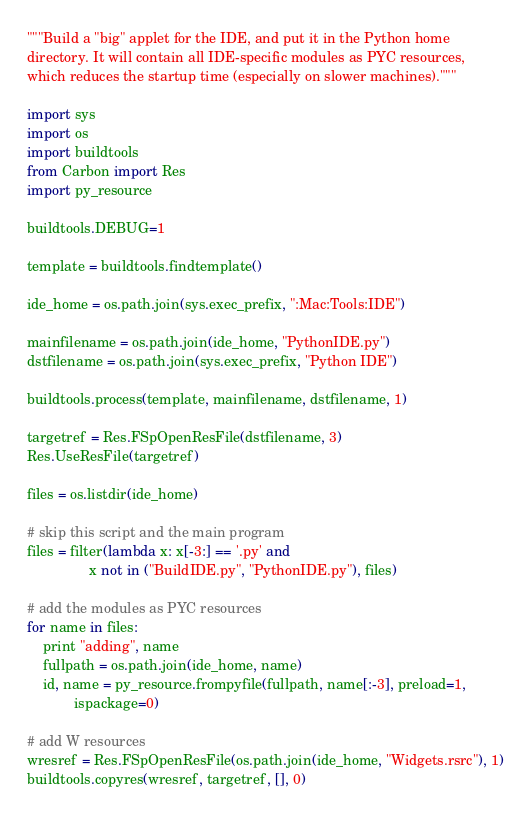Convert code to text. <code><loc_0><loc_0><loc_500><loc_500><_Python_>"""Build a "big" applet for the IDE, and put it in the Python home
directory. It will contain all IDE-specific modules as PYC resources,
which reduces the startup time (especially on slower machines)."""

import sys
import os
import buildtools
from Carbon import Res
import py_resource

buildtools.DEBUG=1

template = buildtools.findtemplate()

ide_home = os.path.join(sys.exec_prefix, ":Mac:Tools:IDE")

mainfilename = os.path.join(ide_home, "PythonIDE.py")
dstfilename = os.path.join(sys.exec_prefix, "Python IDE")

buildtools.process(template, mainfilename, dstfilename, 1)

targetref = Res.FSpOpenResFile(dstfilename, 3)
Res.UseResFile(targetref)

files = os.listdir(ide_home)

# skip this script and the main program
files = filter(lambda x: x[-3:] == '.py' and
                x not in ("BuildIDE.py", "PythonIDE.py"), files)

# add the modules as PYC resources
for name in files:
    print "adding", name
    fullpath = os.path.join(ide_home, name)
    id, name = py_resource.frompyfile(fullpath, name[:-3], preload=1,
            ispackage=0)

# add W resources
wresref = Res.FSpOpenResFile(os.path.join(ide_home, "Widgets.rsrc"), 1)
buildtools.copyres(wresref, targetref, [], 0)
</code> 